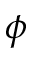<formula> <loc_0><loc_0><loc_500><loc_500>\phi</formula> 